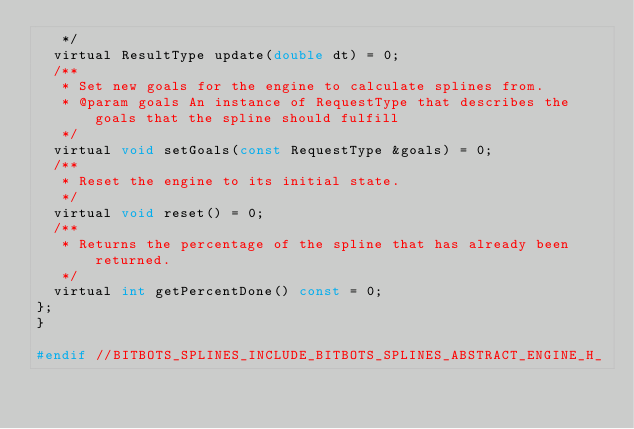Convert code to text. <code><loc_0><loc_0><loc_500><loc_500><_C_>   */
  virtual ResultType update(double dt) = 0;
  /**
   * Set new goals for the engine to calculate splines from.
   * @param goals An instance of RequestType that describes the goals that the spline should fulfill
   */
  virtual void setGoals(const RequestType &goals) = 0;
  /**
   * Reset the engine to its initial state.
   */
  virtual void reset() = 0;
  /**
   * Returns the percentage of the spline that has already been returned.
   */
  virtual int getPercentDone() const = 0;
};
}

#endif //BITBOTS_SPLINES_INCLUDE_BITBOTS_SPLINES_ABSTRACT_ENGINE_H_
</code> 